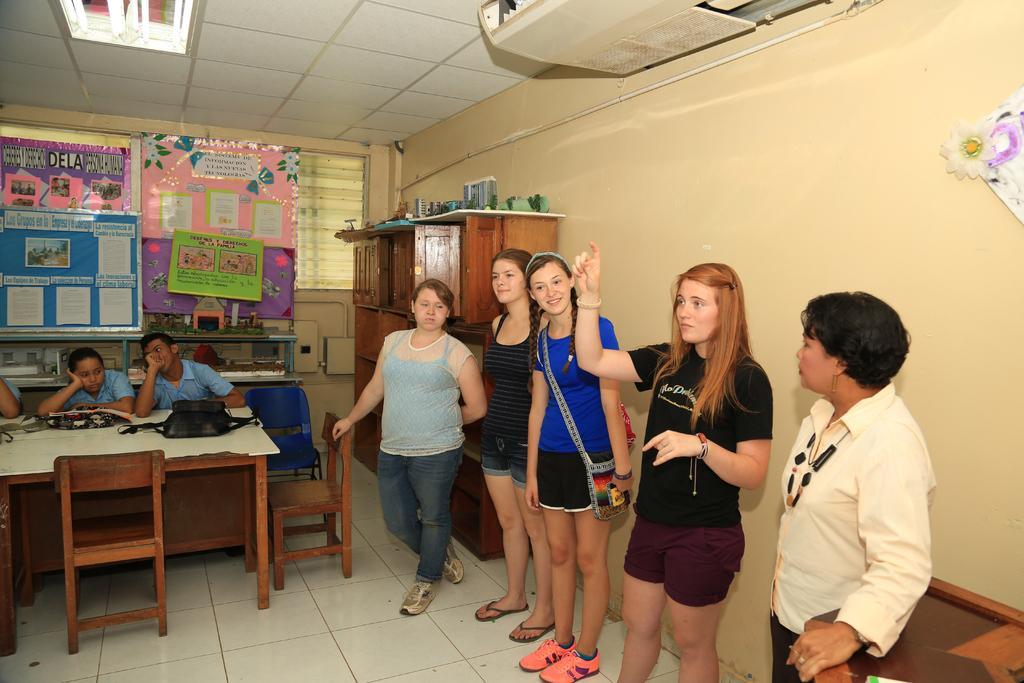Please provide a concise description of this image. In this picture I can see few people are standing and few people are sitting on the chairs, in front of them we can see the table on which we can see few things placed, behind we can see some boards, wooden shelf. 